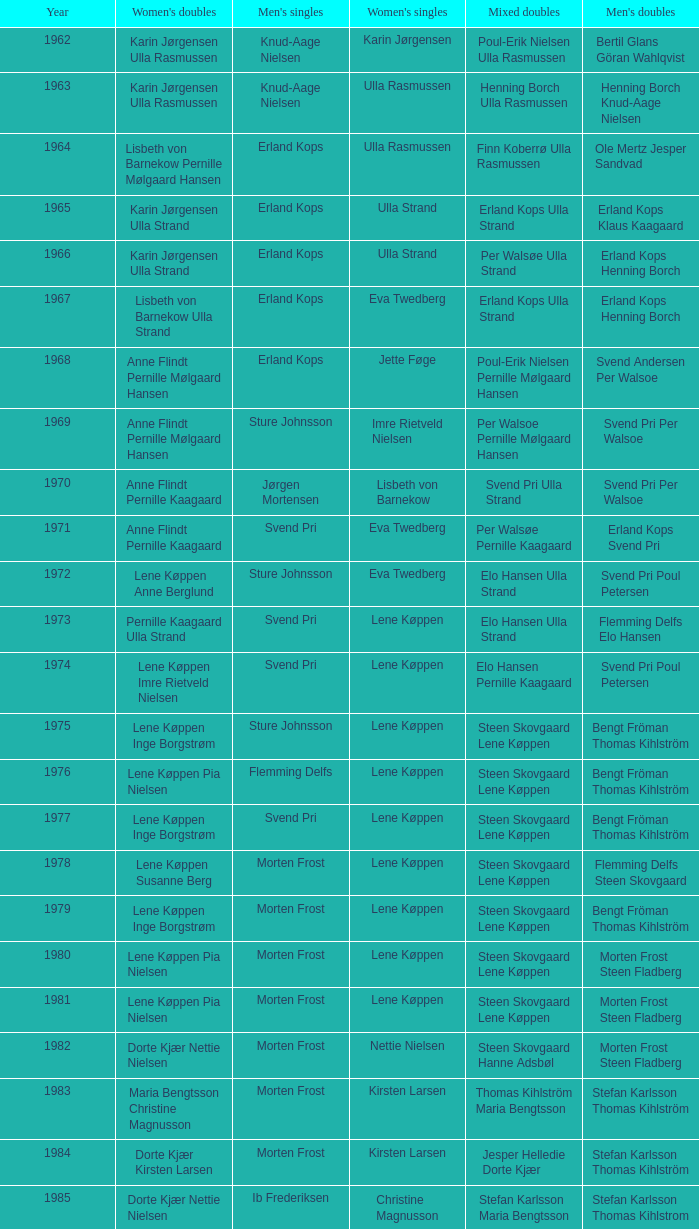Who won the men's doubles the year Pernille Nedergaard won the women's singles? Thomas Stuer-Lauridsen Max Gandrup. 